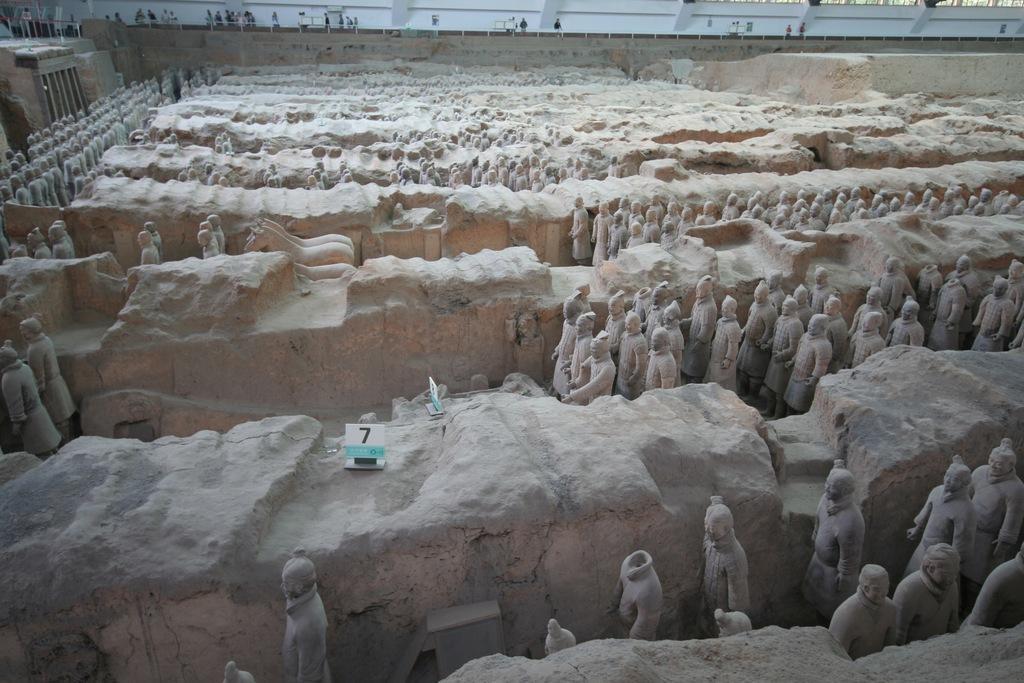Could you give a brief overview of what you see in this image? In the image there are many sculptures and also there are walls. At the top of the image there is a railing. Behind the railing there are few people and also there are white color walls. 